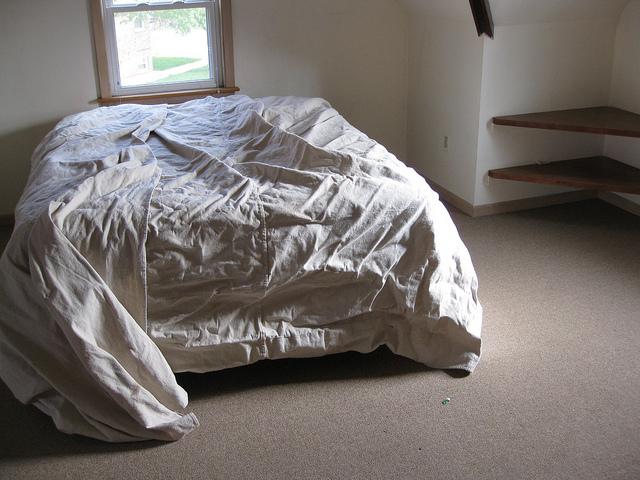Is the window open?
Concise answer only. No. Are the sheets crumbled?
Quick response, please. Yes. Is the bed made?
Answer briefly. No. 